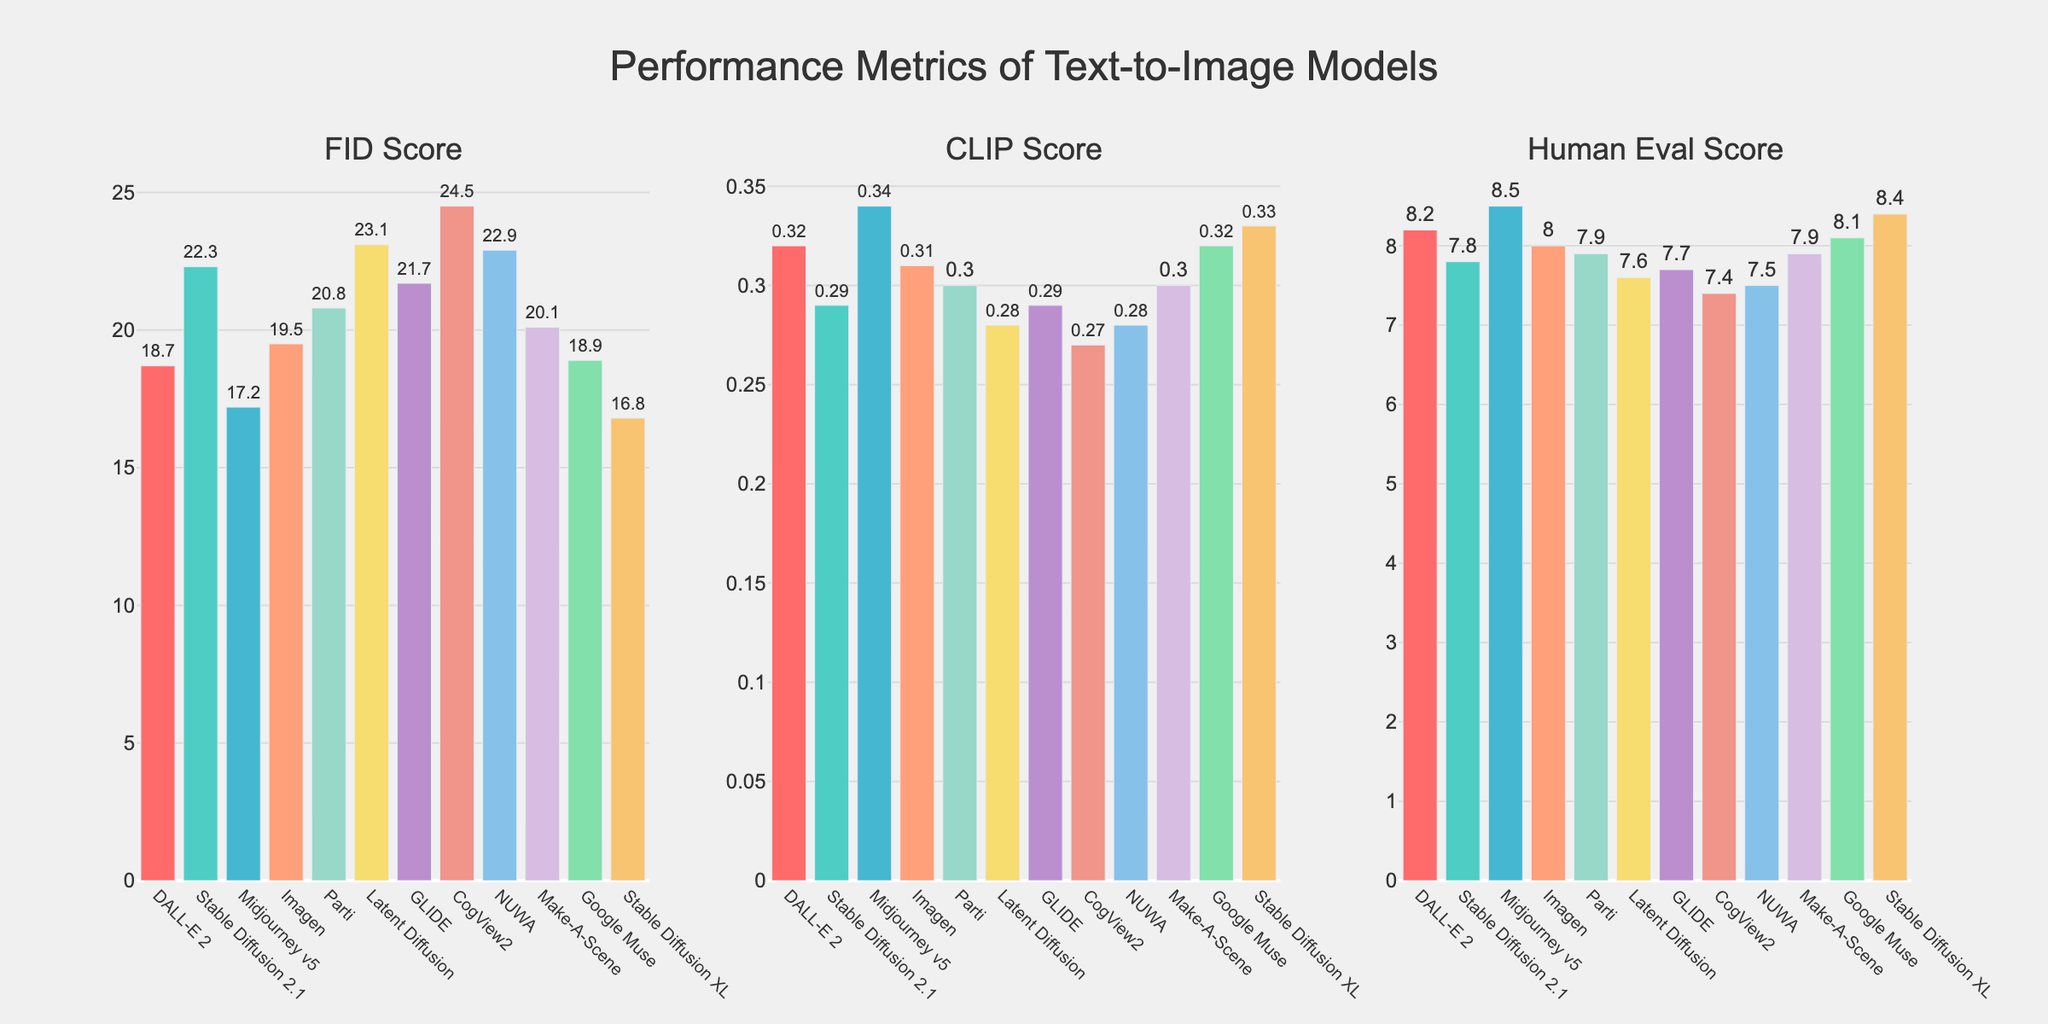Which model has the highest CLIP score? Look at the bar chart for the CLIP Score and identify the highest bar. The highest CLIP Score is for Midjourney v5.
Answer: Midjourney v5 Which two models have the most similar FID scores? Look at the FID Score bars and find the ones that are closest in height. DALL-E 2 and Google Muse have very similar FID scores.
Answer: DALL-E 2, Google Muse What is the sum of the Human Eval Scores of the top three models? Identify the top three models with the highest Human Eval Scores: Midjourney v5, Stable Diffusion XL, and DALL-E 2. Sum their scores: 8.5 + 8.4 + 8.2.
Answer: 25.1 Which model has the lowest FID score, and by how much is it lower than the model with the highest FID score? Look at the FID Score bars and identify the lowest and the highest values. The lowest FID score is for Stable Diffusion XL with 16.8, and the highest is for CogView2 with 24.5. The difference is 24.5 - 16.8.
Answer: Stable Diffusion XL, 7.7 Compare the Human Eval Scores of DALL-E 2 and Imagen. Which one is higher and by how much? Find the Human Eval Scores for both models. DALL-E 2 has a score of 8.2 and Imagen has a score of 8.0. The difference is 8.2 - 8.0.
Answer: DALL-E 2, 0.2 What is the average CLIP Score across all models? Sum all the CLIP Scores and divide by the number of models. (0.32 + 0.29 + 0.34 + 0.31 + 0.30 + 0.28 + 0.29 + 0.27 + 0.28 + 0.30 + 0.32 + 0.33) / 12.
Answer: 0.30 Which model has a higher FID score: Stable Diffusion 2.1 or Parti? Compare the FID Scores for these two models. Stable Diffusion 2.1 has a score of 22.3 and Parti has a score of 20.8.
Answer: Stable Diffusion 2.1 What is the median Human Eval Score? Arrange the Human Eval Scores in ascending order and find the middle value. The scores are: 7.4, 7.5, 7.6, 7.7, 7.8, 7.9, 7.9, 8.0, 8.1, 8.2, 8.4, 8.5. The median is (7.9 + 8.0) / 2.
Answer: 7.95 